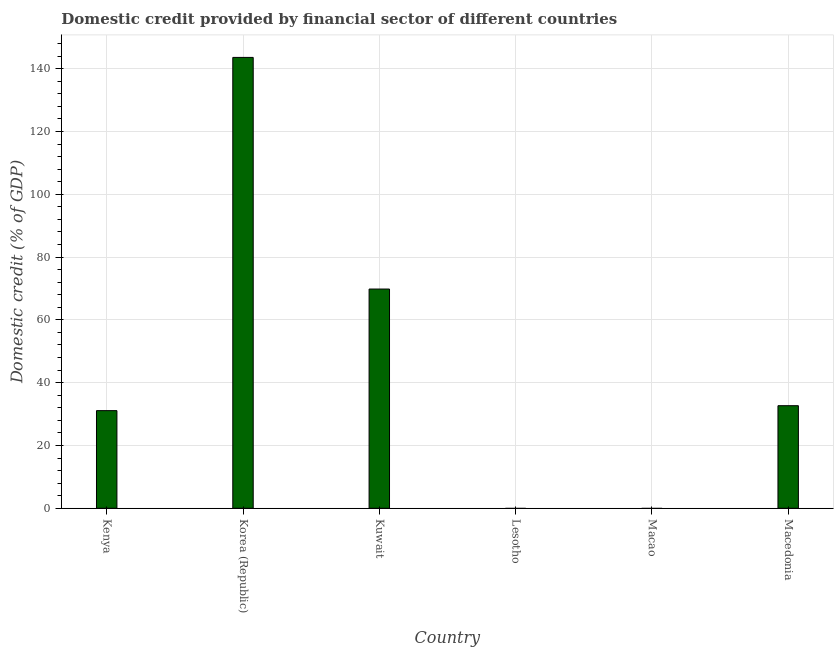What is the title of the graph?
Keep it short and to the point. Domestic credit provided by financial sector of different countries. What is the label or title of the Y-axis?
Make the answer very short. Domestic credit (% of GDP). What is the domestic credit provided by financial sector in Korea (Republic)?
Your answer should be very brief. 143.58. Across all countries, what is the maximum domestic credit provided by financial sector?
Provide a short and direct response. 143.58. In which country was the domestic credit provided by financial sector maximum?
Offer a terse response. Korea (Republic). What is the sum of the domestic credit provided by financial sector?
Give a very brief answer. 277.16. What is the difference between the domestic credit provided by financial sector in Kenya and Korea (Republic)?
Offer a terse response. -112.49. What is the average domestic credit provided by financial sector per country?
Keep it short and to the point. 46.19. What is the median domestic credit provided by financial sector?
Provide a short and direct response. 31.88. What is the ratio of the domestic credit provided by financial sector in Kenya to that in Kuwait?
Offer a terse response. 0.45. Is the domestic credit provided by financial sector in Korea (Republic) less than that in Kuwait?
Give a very brief answer. No. Is the difference between the domestic credit provided by financial sector in Kuwait and Macedonia greater than the difference between any two countries?
Make the answer very short. No. What is the difference between the highest and the second highest domestic credit provided by financial sector?
Make the answer very short. 73.76. Is the sum of the domestic credit provided by financial sector in Kenya and Korea (Republic) greater than the maximum domestic credit provided by financial sector across all countries?
Provide a short and direct response. Yes. What is the difference between the highest and the lowest domestic credit provided by financial sector?
Offer a terse response. 143.58. In how many countries, is the domestic credit provided by financial sector greater than the average domestic credit provided by financial sector taken over all countries?
Make the answer very short. 2. How many bars are there?
Provide a short and direct response. 4. What is the Domestic credit (% of GDP) of Kenya?
Your answer should be very brief. 31.09. What is the Domestic credit (% of GDP) in Korea (Republic)?
Provide a succinct answer. 143.58. What is the Domestic credit (% of GDP) of Kuwait?
Ensure brevity in your answer.  69.82. What is the Domestic credit (% of GDP) in Macao?
Your response must be concise. 0. What is the Domestic credit (% of GDP) of Macedonia?
Ensure brevity in your answer.  32.67. What is the difference between the Domestic credit (% of GDP) in Kenya and Korea (Republic)?
Offer a very short reply. -112.49. What is the difference between the Domestic credit (% of GDP) in Kenya and Kuwait?
Ensure brevity in your answer.  -38.72. What is the difference between the Domestic credit (% of GDP) in Kenya and Macedonia?
Make the answer very short. -1.57. What is the difference between the Domestic credit (% of GDP) in Korea (Republic) and Kuwait?
Your response must be concise. 73.76. What is the difference between the Domestic credit (% of GDP) in Korea (Republic) and Macedonia?
Your response must be concise. 110.91. What is the difference between the Domestic credit (% of GDP) in Kuwait and Macedonia?
Offer a very short reply. 37.15. What is the ratio of the Domestic credit (% of GDP) in Kenya to that in Korea (Republic)?
Keep it short and to the point. 0.22. What is the ratio of the Domestic credit (% of GDP) in Kenya to that in Kuwait?
Offer a terse response. 0.45. What is the ratio of the Domestic credit (% of GDP) in Korea (Republic) to that in Kuwait?
Your answer should be very brief. 2.06. What is the ratio of the Domestic credit (% of GDP) in Korea (Republic) to that in Macedonia?
Make the answer very short. 4.39. What is the ratio of the Domestic credit (% of GDP) in Kuwait to that in Macedonia?
Ensure brevity in your answer.  2.14. 